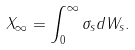<formula> <loc_0><loc_0><loc_500><loc_500>X _ { \infty } = \int _ { 0 } ^ { \infty } \sigma _ { s } d W _ { s } .</formula> 